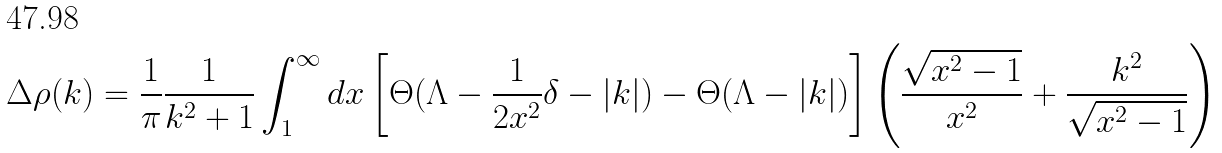Convert formula to latex. <formula><loc_0><loc_0><loc_500><loc_500>\Delta \rho ( k ) = \frac { 1 } { \pi } \frac { 1 } { k ^ { 2 } + 1 } \int _ { 1 } ^ { \infty } d x \left [ \Theta ( \Lambda - \frac { 1 } { 2 x ^ { 2 } } \delta - | k | ) - \Theta ( \Lambda - | k | ) \right ] \left ( \frac { \sqrt { x ^ { 2 } - 1 } } { x ^ { 2 } } + \frac { k ^ { 2 } } { \sqrt { x ^ { 2 } - 1 } } \right )</formula> 